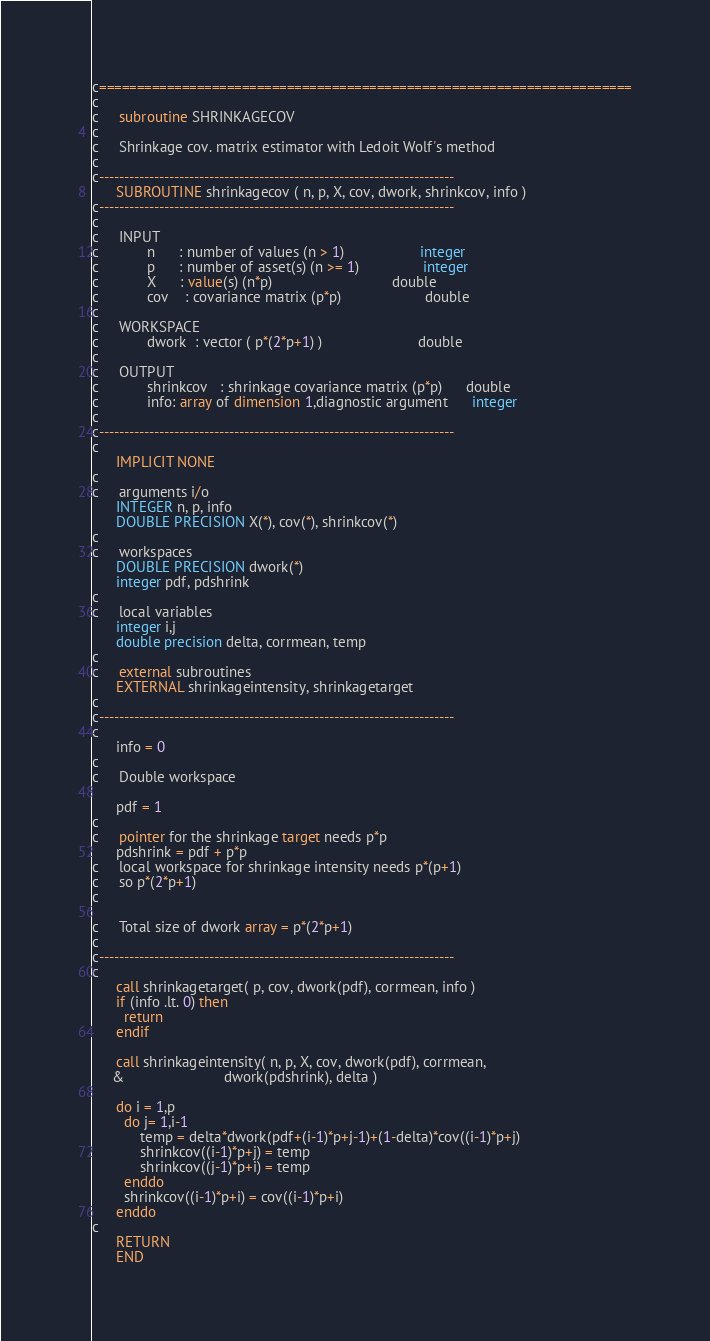Convert code to text. <code><loc_0><loc_0><loc_500><loc_500><_FORTRAN_>c=======================================================================
c
c     subroutine SHRINKAGECOV                                        
c
c     Shrinkage cov. matrix estimator with Ledoit Wolf's method
c
c-----------------------------------------------------------------------
      SUBROUTINE shrinkagecov ( n, p, X, cov, dwork, shrinkcov, info )
c-----------------------------------------------------------------------
c
c     INPUT 
c            n      : number of values (n > 1)                   integer
c            p      : number of asset(s) (n >= 1)                integer
c            X      : value(s) (n*p)                              double
c            cov    : covariance matrix (p*p)                     double 
c
c     WORKSPACE
c            dwork  : vector ( p*(2*p+1) )                        double
c
c     OUTPUT
c            shrinkcov   : shrinkage covariance matrix (p*p)      double  
c            info: array of dimension 1,diagnostic argument      integer
c
c-----------------------------------------------------------------------
c
      IMPLICIT NONE
c
c     arguments i/o
      INTEGER n, p, info
      DOUBLE PRECISION X(*), cov(*), shrinkcov(*)
c
c     workspaces     
      DOUBLE PRECISION dwork(*)
      integer pdf, pdshrink
c
c     local variables
      integer i,j 
      double precision delta, corrmean, temp
c
c     external subroutines
      EXTERNAL shrinkageintensity, shrinkagetarget
c
c-----------------------------------------------------------------------
c
      info = 0
c
c     Double workspace 

      pdf = 1 
c
c     pointer for the shrinkage target needs p*p 
      pdshrink = pdf + p*p
c     local workspace for shrinkage intensity needs p*(p+1)
c     so p*(2*p+1)
c
            
c     Total size of dwork array = p*(2*p+1) 
c
c-----------------------------------------------------------------------
c     
      call shrinkagetarget( p, cov, dwork(pdf), corrmean, info )
      if (info .lt. 0) then
        return
      endif
      
      call shrinkageintensity( n, p, X, cov, dwork(pdf), corrmean,
     &                         dwork(pdshrink), delta )
      
      do i = 1,p
        do j= 1,i-1
            temp = delta*dwork(pdf+(i-1)*p+j-1)+(1-delta)*cov((i-1)*p+j)
            shrinkcov((i-1)*p+j) = temp
            shrinkcov((j-1)*p+i) = temp
        enddo
        shrinkcov((i-1)*p+i) = cov((i-1)*p+i)
      enddo
c
      RETURN
      END

</code> 